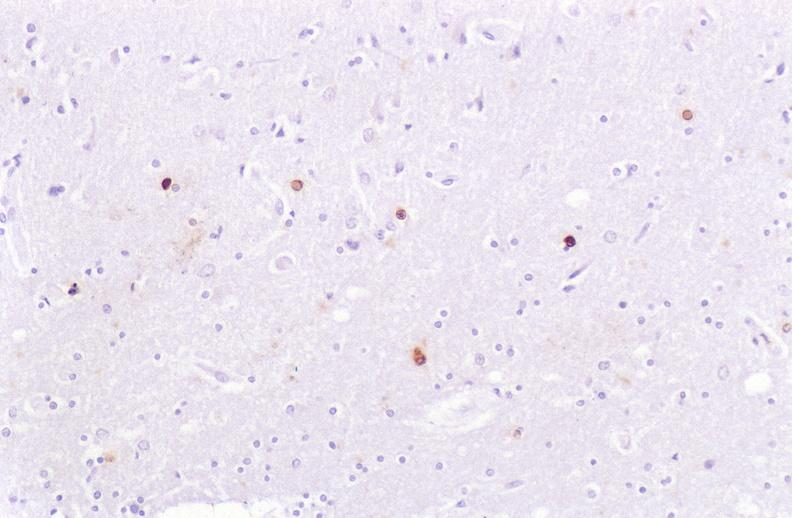what is present?
Answer the question using a single word or phrase. Nervous 